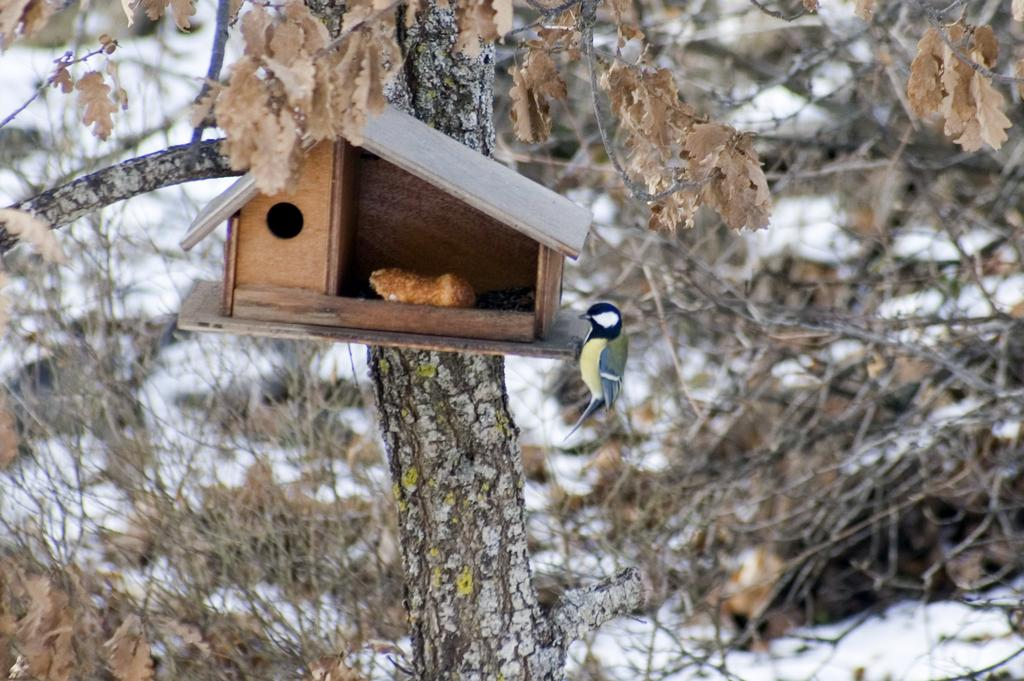What is the main object in the image? There is a tree in the image. What is attached to the tree? There is a small hut for birds on the trunk of the tree. Is there any bird activity near the hut? Yes, a bird is standing beside the hut. What can be seen in the background of the image? There are dry plants and snow visible in the background of the image. What type of veil is the bird wearing in the image? There is no veil present in the image; the bird is not wearing any clothing or accessories. Can you tell me how the bird is interacting with the goldfish in the image? There is no goldfish present in the image; the bird is standing beside the bird hut. 